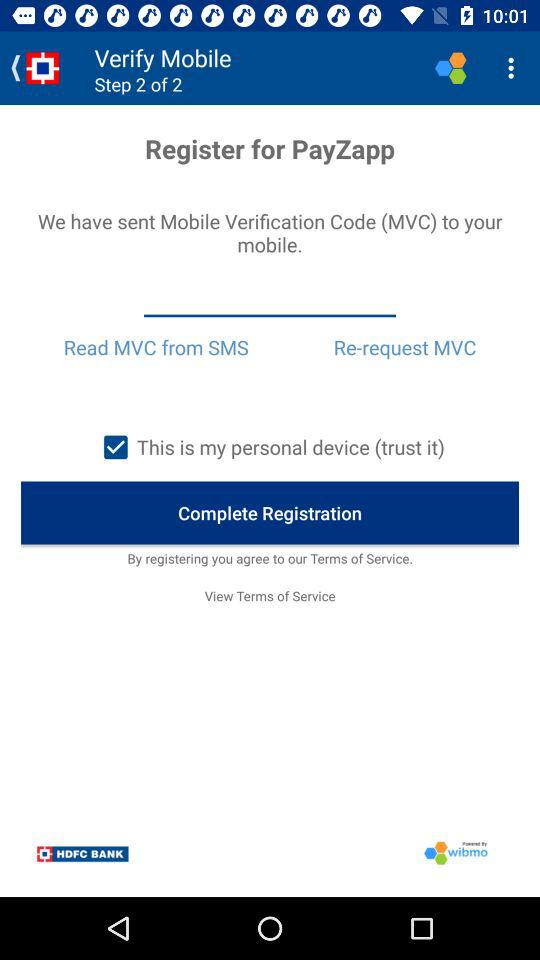What is the status of "This is my personal device"? The status is "on". 